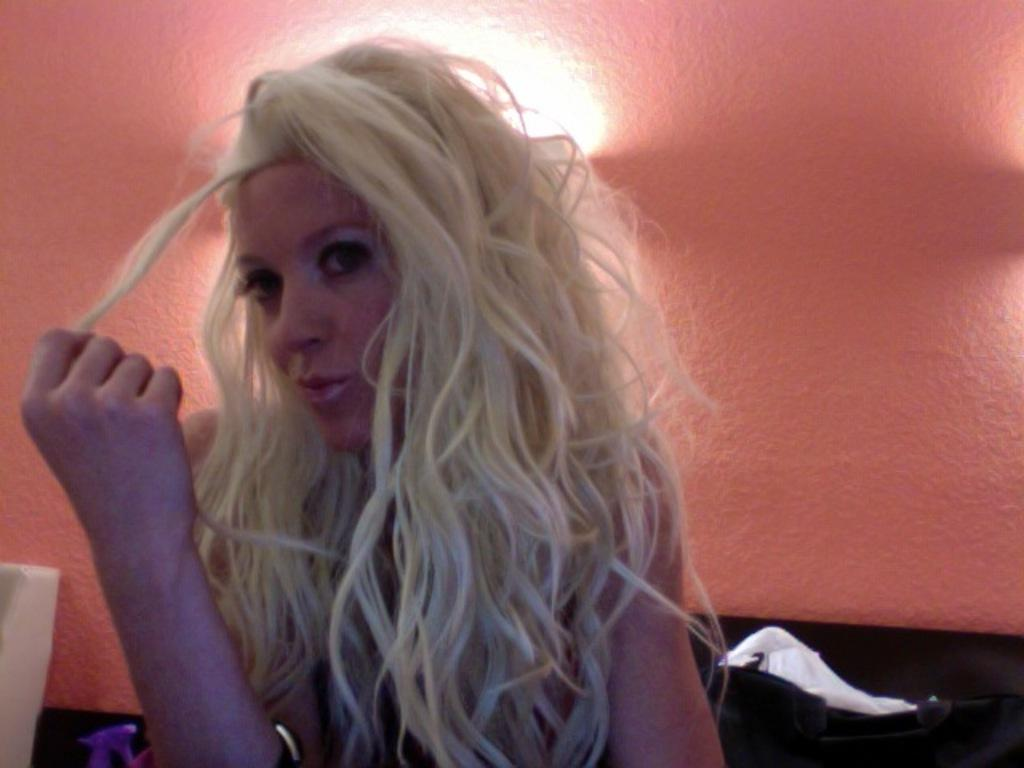Who is present in the image? There is a woman in the image. What can be seen behind the woman? The woman is sitting near a saffron-colored wall. What is attached to the wall? There is a light attached to the wall. What else can be seen near the woman? There are objects near the woman. What type of zinc material is draped over the woman's shoulder in the image? There is no zinc material present in the image. What type of silk fabric is visible on the woman's dress in the image? The woman's clothing is not described in the provided facts, so we cannot determine the type of fabric. 